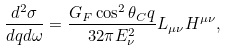<formula> <loc_0><loc_0><loc_500><loc_500>\frac { d ^ { 2 } \sigma } { d q d \omega } = \frac { G _ { F } \cos ^ { 2 } \theta _ { C } q } { 3 2 \pi E _ { \nu } ^ { 2 } } L _ { \mu \nu } H ^ { \mu \nu } ,</formula> 